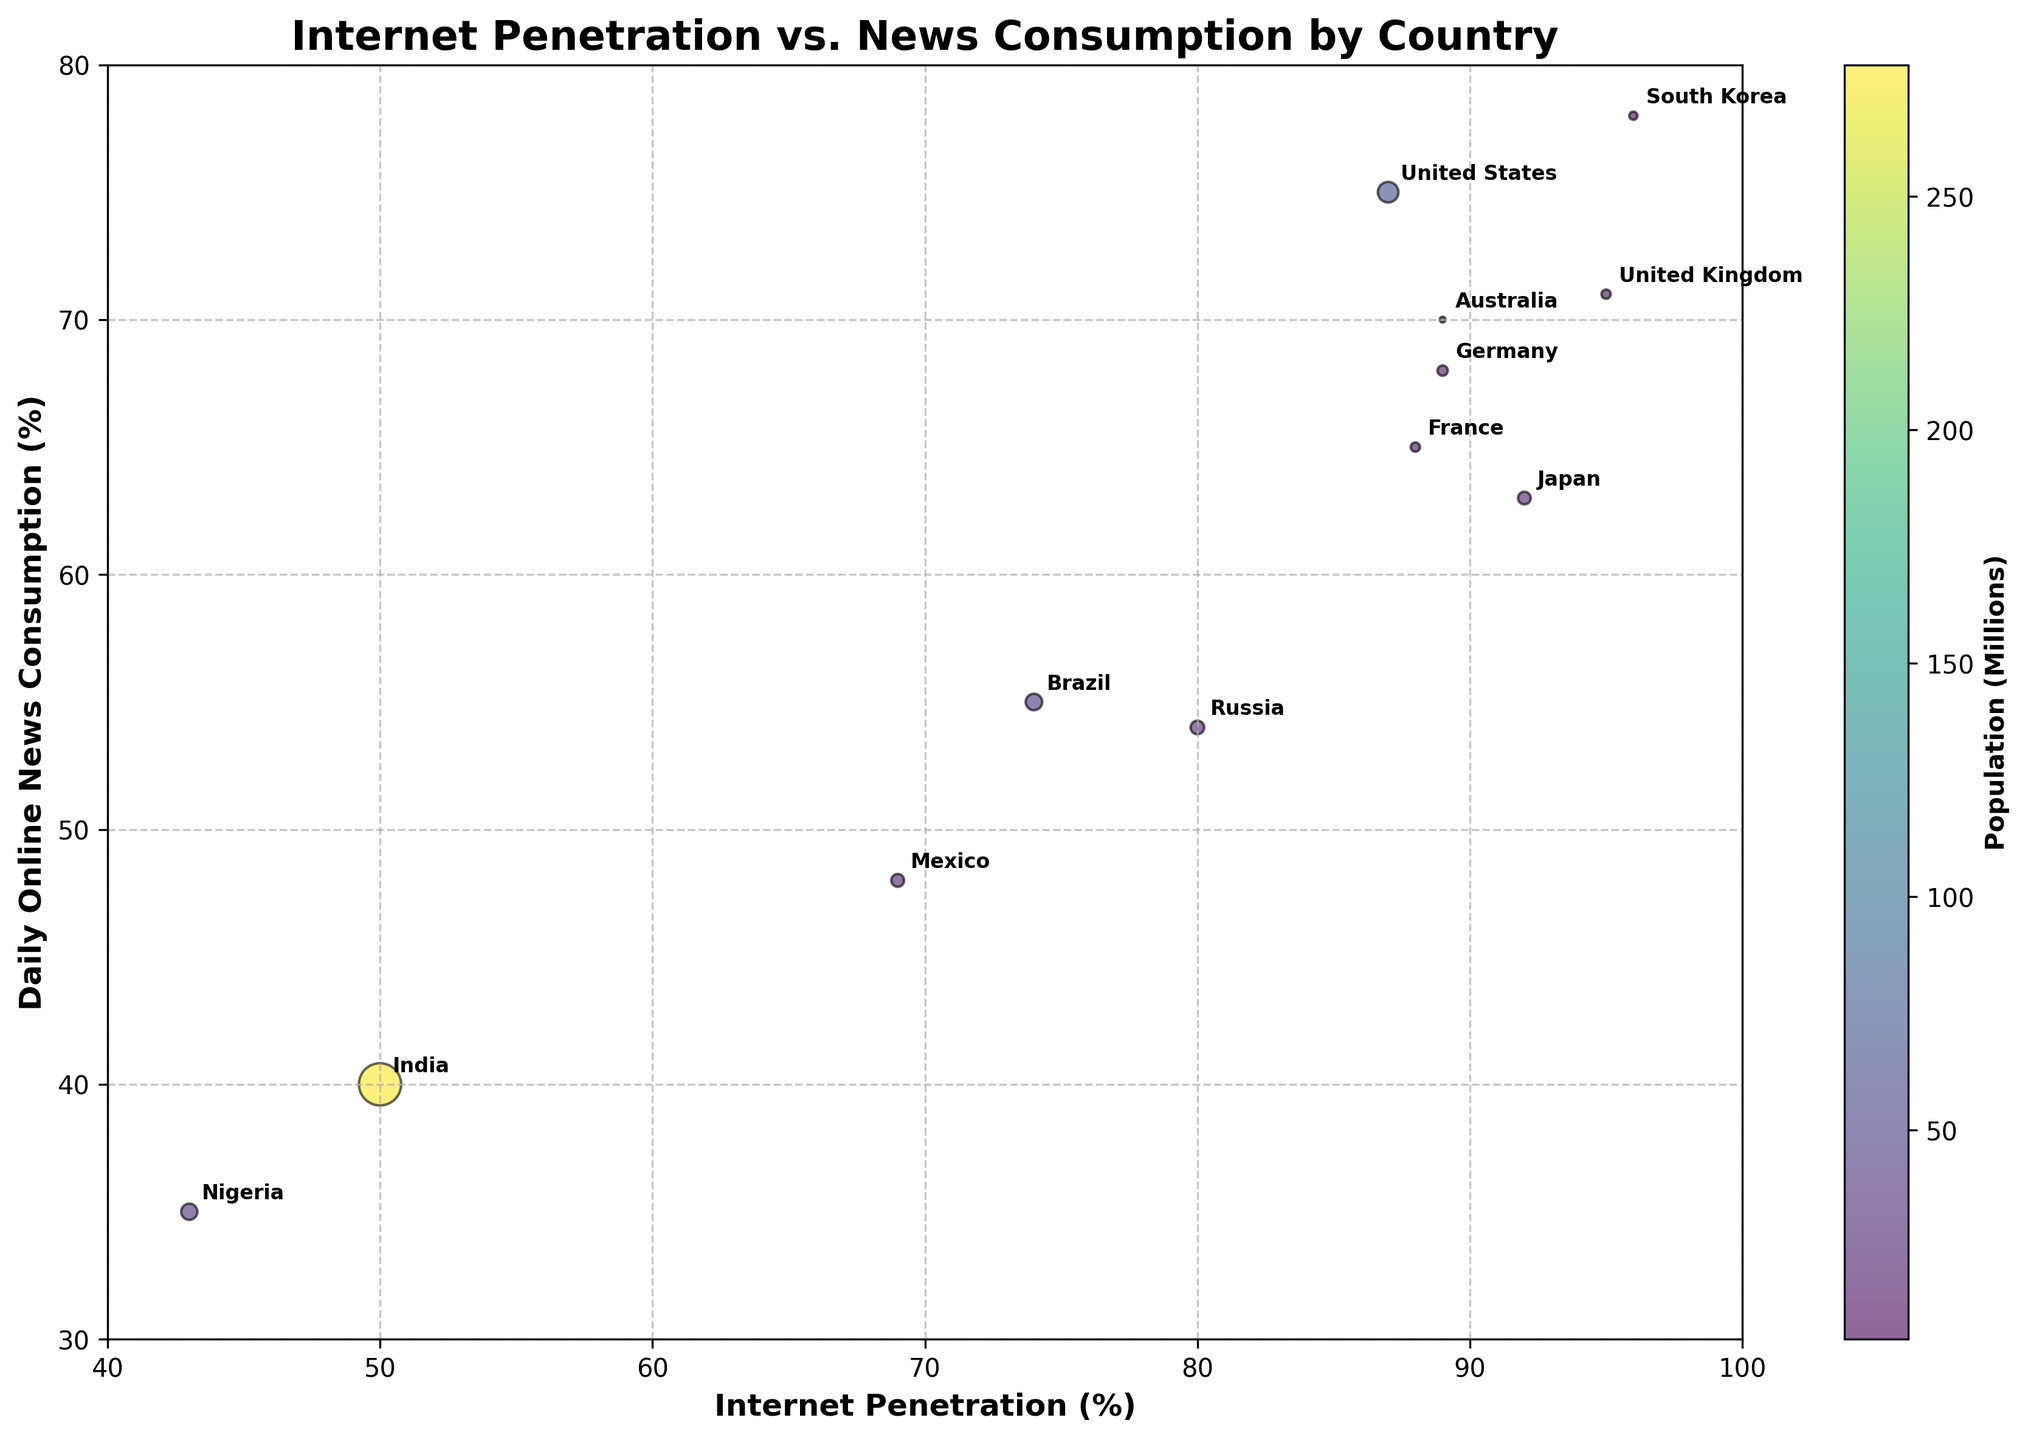What is the title of the figure? The title is mentioned at the top of the figure.
Answer: Internet Penetration vs. News Consumption by Country What is the population of the country with the highest internet penetration? The highest internet penetration is 96%, which corresponds to South Korea. Its population, indicated by the bubble size and annotation, is 52 million.
Answer: 52 million Which country has the lowest daily online news consumption percentage? The figure shows the lowest point on the y-axis for daily online news consumption is 35%, which corresponds to Nigeria.
Answer: Nigeria Compare the daily news consumption percentages of Japan and the United States. Japan has a daily news consumption percentage of 63%, while the United States has 75%. From the chart, we see that Japan's value is lower compared to the United States.
Answer: United States has higher What is the average internet penetration for Brazil and Mexico? The internet penetration for Brazil is 74% and for Mexico is 69%. The average is calculated as (74 + 69) / 2 = 71.5%.
Answer: 71.5% Which country has the smallest bubble size and what does it represent? The smallest bubble size corresponds to Australia's 26 million population, indicating it has the smallest population among the listed countries.
Answer: Australia What is the internet penetration range on the x-axis? The x-axis range spans from the lowest value, which is 40%, to the highest value being 100%. Thus, the range is from 40% to 100%.
Answer: 40% to 100% Which country has a higher daily online news consumption, Germany or France? Germany has a daily news consumption of 68% while France has 65%. Comparing these, Germany has a higher percentage than France.
Answer: Germany What is the combined population of India and Nigeria? The population of India is 1391 million, and Nigeria is 206 million. Summing these gives 1391 + 206 = 1597 million.
Answer: 1597 million Does a higher internet penetration always correlate with higher daily online news consumption in the given countries? Observing the scatter plot, not all countries with high internet penetration have higher news consumption. For example, Japan has a high internet penetration but lower daily news consumption compared to the United States.
Answer: No 